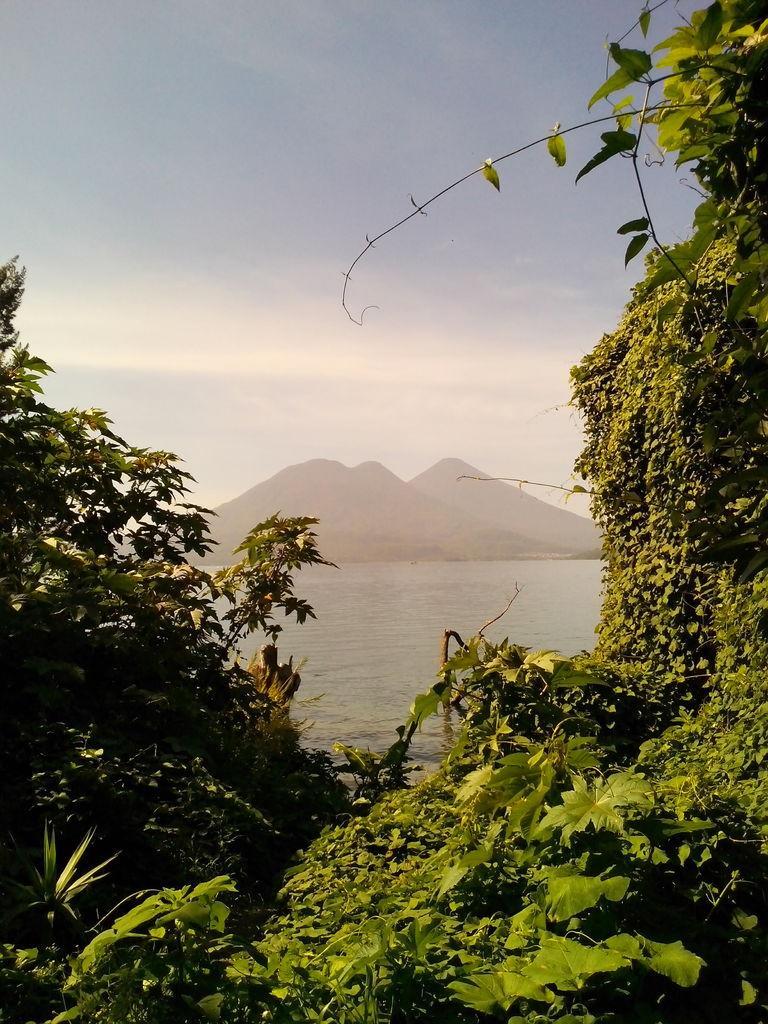Could you give a brief overview of what you see in this image? In this picture we can describe about a beautiful view of the nature. In front we can see many trees and plants. Behind we can see a lake water. In the background we can see huge brown mountain and a blue clear sky. 